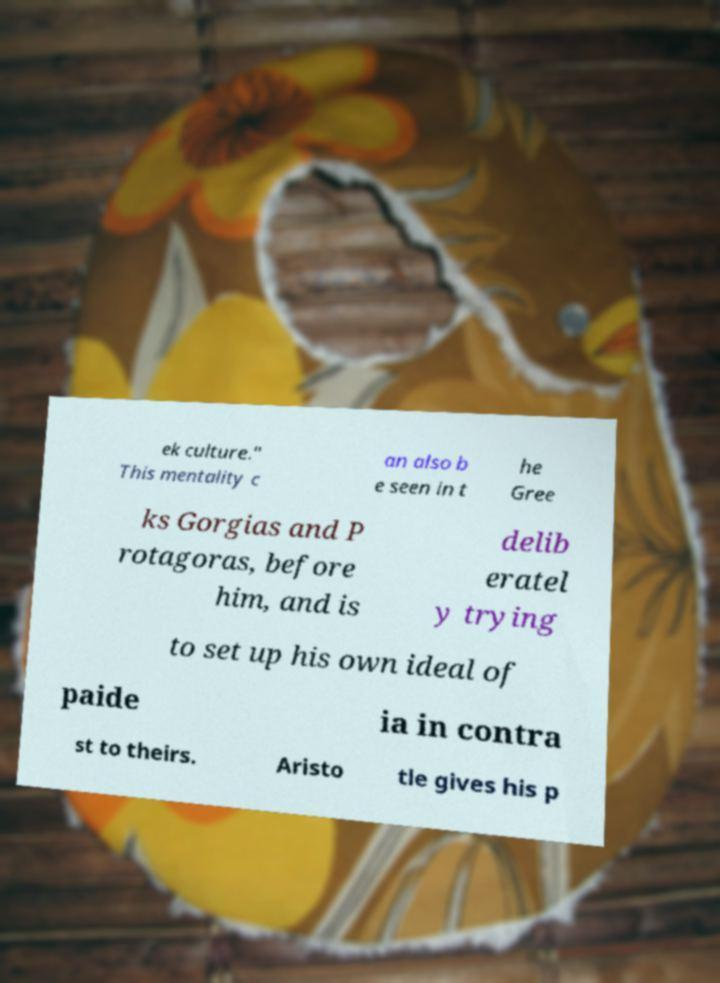There's text embedded in this image that I need extracted. Can you transcribe it verbatim? ek culture." This mentality c an also b e seen in t he Gree ks Gorgias and P rotagoras, before him, and is delib eratel y trying to set up his own ideal of paide ia in contra st to theirs. Aristo tle gives his p 